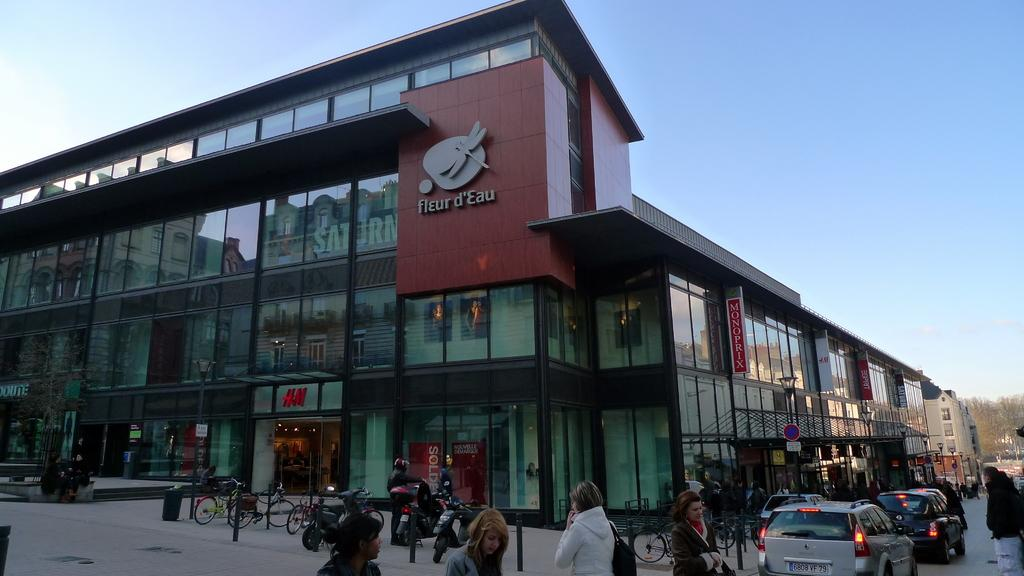What type of structure is visible in the image? There is a building in the image. Who or what can be seen in the image besides the building? There are people, bicycles, and cars visible in the image. What is the setting of the image? The image shows a road with people, bicycles, and cars. What can be seen in the background of the image? There are trees and the sky visible in the background of the image. Can you tell me how many horses are pulling the cars in the image? There are no horses present in the image; the cars are not being pulled by any animals. 